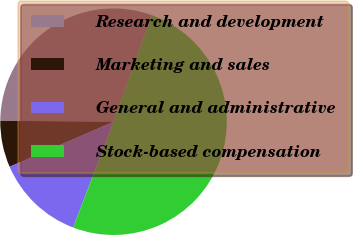Convert chart to OTSL. <chart><loc_0><loc_0><loc_500><loc_500><pie_chart><fcel>Research and development<fcel>Marketing and sales<fcel>General and administrative<fcel>Stock-based compensation<nl><fcel>30.35%<fcel>6.65%<fcel>12.68%<fcel>50.31%<nl></chart> 